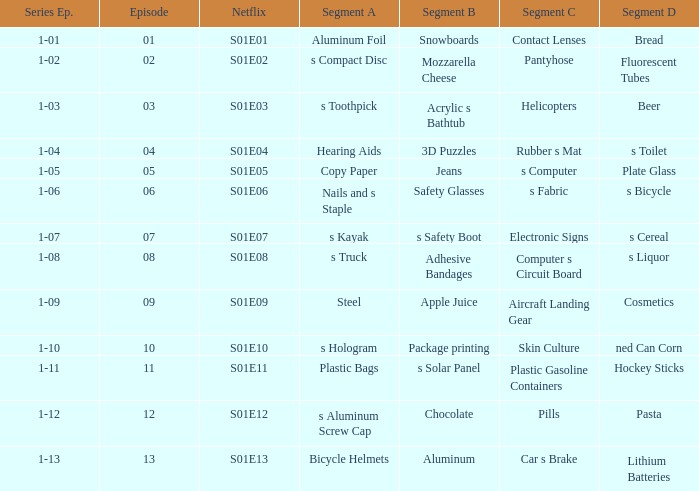Write the full table. {'header': ['Series Ep.', 'Episode', 'Netflix', 'Segment A', 'Segment B', 'Segment C', 'Segment D'], 'rows': [['1-01', '01', 'S01E01', 'Aluminum Foil', 'Snowboards', 'Contact Lenses', 'Bread'], ['1-02', '02', 'S01E02', 's Compact Disc', 'Mozzarella Cheese', 'Pantyhose', 'Fluorescent Tubes'], ['1-03', '03', 'S01E03', 's Toothpick', 'Acrylic s Bathtub', 'Helicopters', 'Beer'], ['1-04', '04', 'S01E04', 'Hearing Aids', '3D Puzzles', 'Rubber s Mat', 's Toilet'], ['1-05', '05', 'S01E05', 'Copy Paper', 'Jeans', 's Computer', 'Plate Glass'], ['1-06', '06', 'S01E06', 'Nails and s Staple', 'Safety Glasses', 's Fabric', 's Bicycle'], ['1-07', '07', 'S01E07', 's Kayak', 's Safety Boot', 'Electronic Signs', 's Cereal'], ['1-08', '08', 'S01E08', 's Truck', 'Adhesive Bandages', 'Computer s Circuit Board', 's Liquor'], ['1-09', '09', 'S01E09', 'Steel', 'Apple Juice', 'Aircraft Landing Gear', 'Cosmetics'], ['1-10', '10', 'S01E10', 's Hologram', 'Package printing', 'Skin Culture', 'ned Can Corn'], ['1-11', '11', 'S01E11', 'Plastic Bags', 's Solar Panel', 'Plastic Gasoline Containers', 'Hockey Sticks'], ['1-12', '12', 'S01E12', 's Aluminum Screw Cap', 'Chocolate', 'Pills', 'Pasta'], ['1-13', '13', 'S01E13', 'Bicycle Helmets', 'Aluminum', 'Car s Brake', 'Lithium Batteries']]} For a segment D of pasta, what is the segment B? Chocolate. 